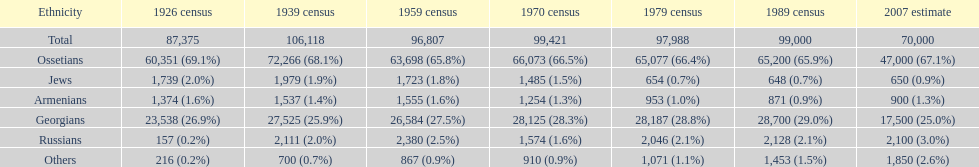Who is previous of the russians based on the list? Georgians. 